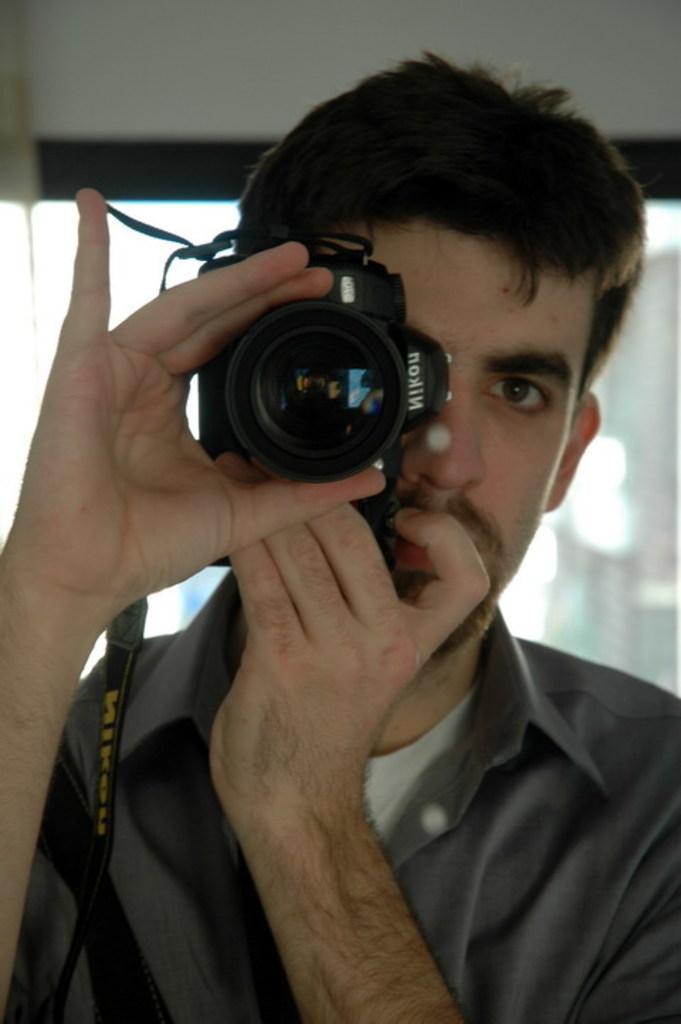Describe this image in one or two sentences. In this image we can see one man holding a camera and taking a photo. One wall in the background at the top of the image, some objects in the background and the background is blurred. 